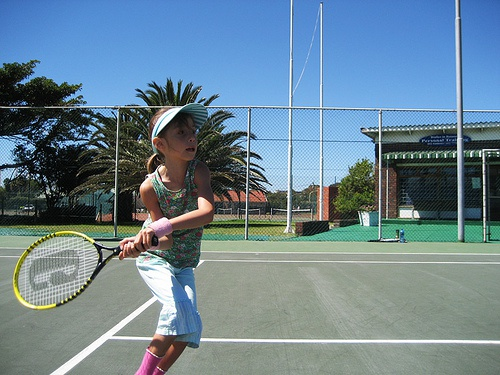Describe the objects in this image and their specific colors. I can see people in blue, black, maroon, white, and gray tones, tennis racket in blue, darkgray, lightgray, black, and gray tones, and potted plant in blue, white, teal, gray, and black tones in this image. 